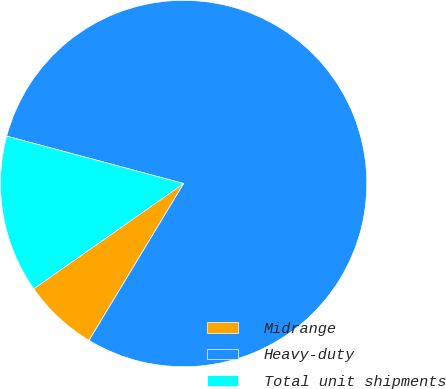Convert chart. <chart><loc_0><loc_0><loc_500><loc_500><pie_chart><fcel>Midrange<fcel>Heavy-duty<fcel>Total unit shipments<nl><fcel>6.62%<fcel>79.47%<fcel>13.91%<nl></chart> 